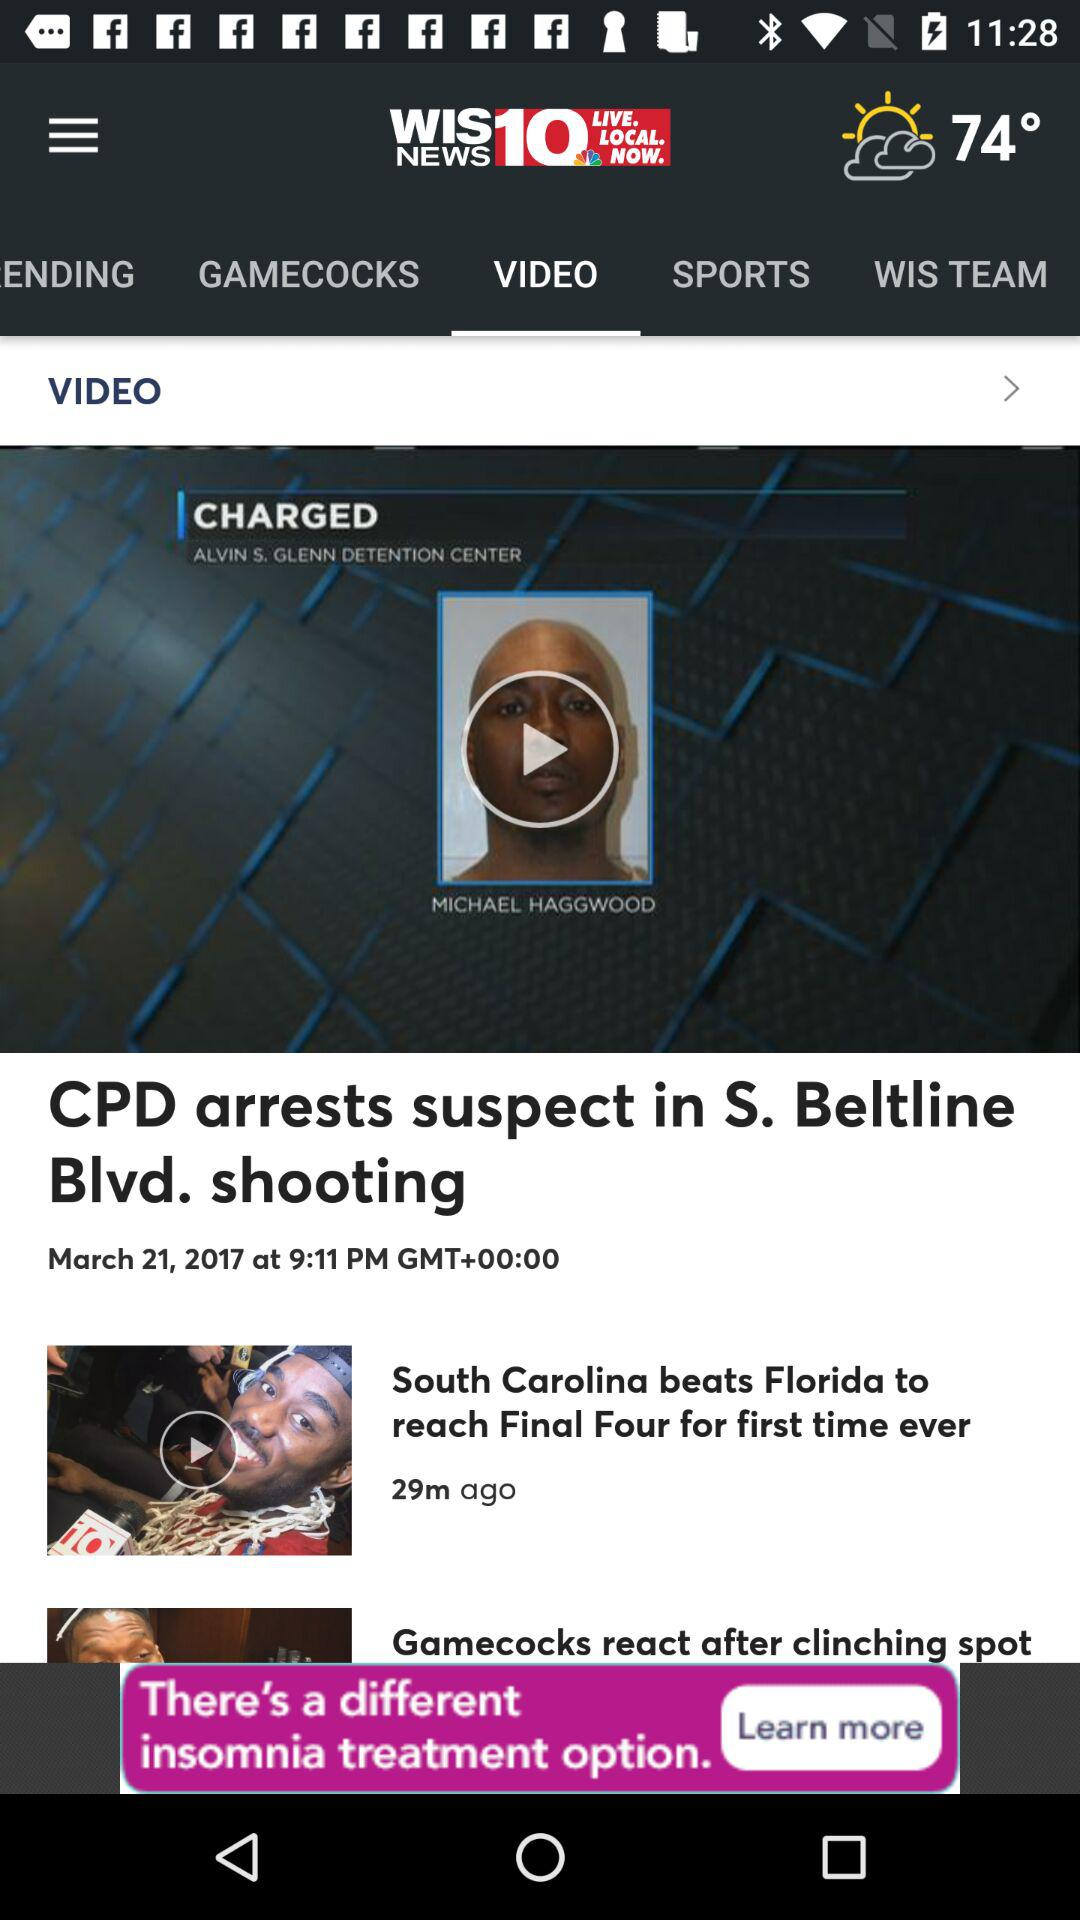What's the weather showing in the news?
When the provided information is insufficient, respond with <no answer>. <no answer> 